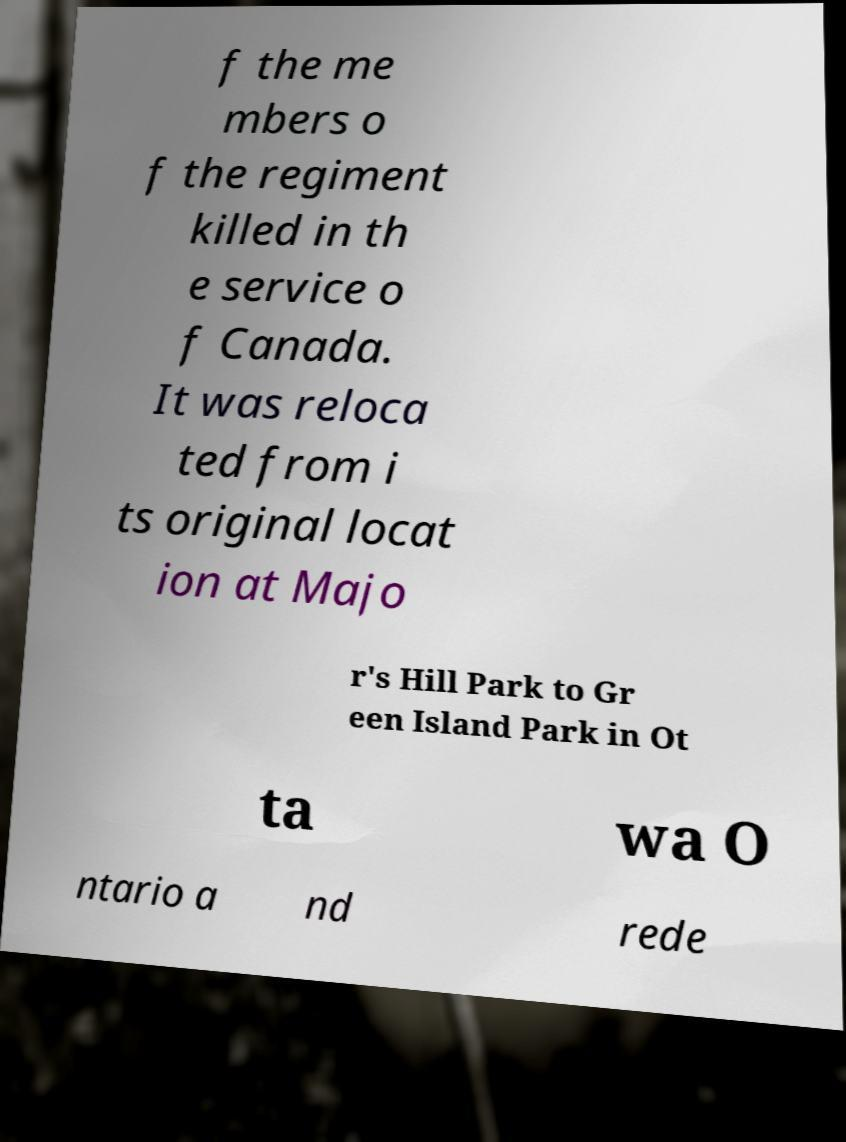What messages or text are displayed in this image? I need them in a readable, typed format. f the me mbers o f the regiment killed in th e service o f Canada. It was reloca ted from i ts original locat ion at Majo r's Hill Park to Gr een Island Park in Ot ta wa O ntario a nd rede 